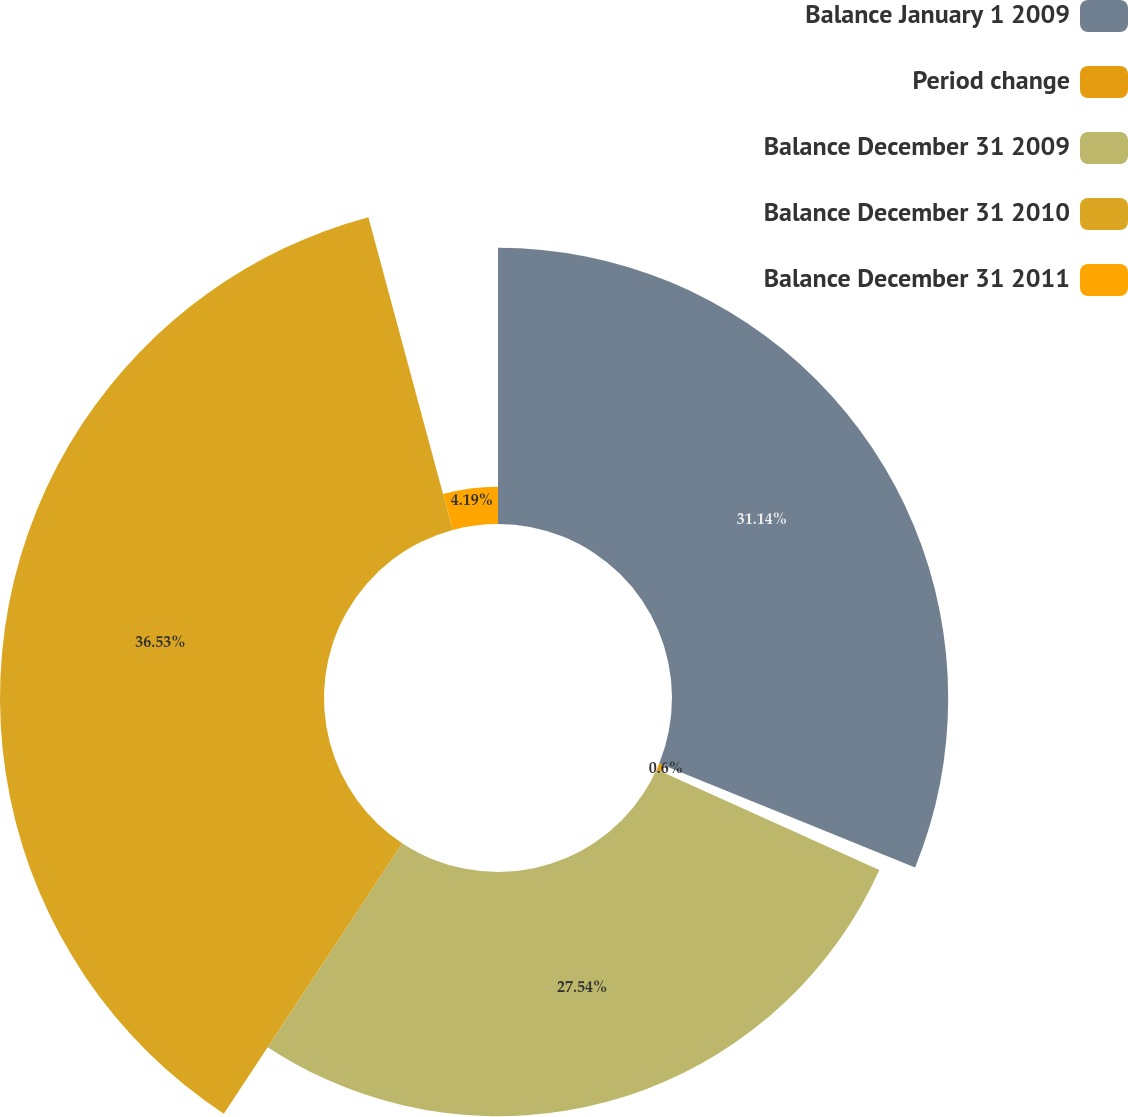Convert chart to OTSL. <chart><loc_0><loc_0><loc_500><loc_500><pie_chart><fcel>Balance January 1 2009<fcel>Period change<fcel>Balance December 31 2009<fcel>Balance December 31 2010<fcel>Balance December 31 2011<nl><fcel>31.14%<fcel>0.6%<fcel>27.54%<fcel>36.53%<fcel>4.19%<nl></chart> 